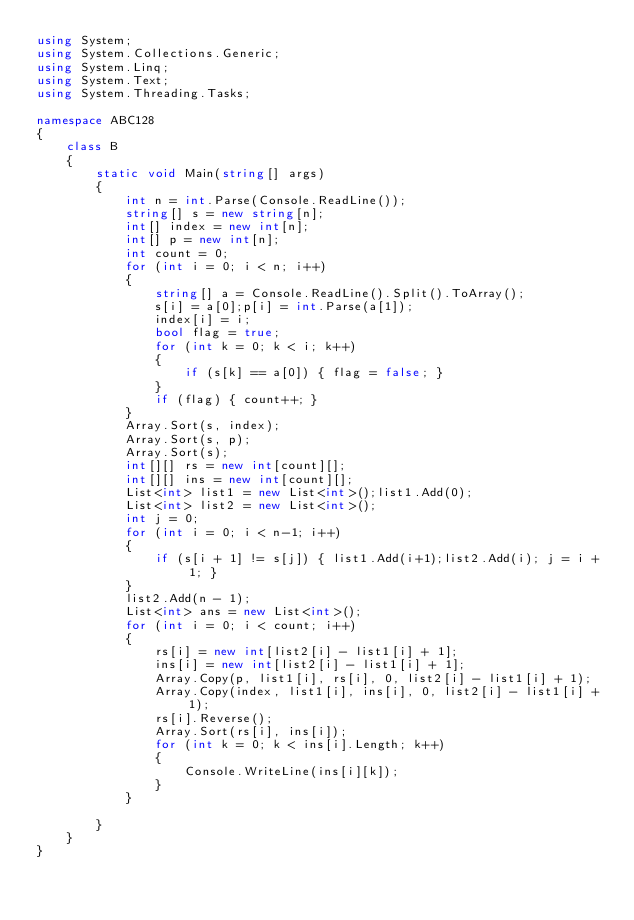Convert code to text. <code><loc_0><loc_0><loc_500><loc_500><_C#_>using System;
using System.Collections.Generic;
using System.Linq;
using System.Text;
using System.Threading.Tasks;

namespace ABC128
{
    class B
    {
        static void Main(string[] args)
        {
            int n = int.Parse(Console.ReadLine());
            string[] s = new string[n];
            int[] index = new int[n];
            int[] p = new int[n];
            int count = 0;
            for (int i = 0; i < n; i++)
            {
                string[] a = Console.ReadLine().Split().ToArray();
                s[i] = a[0];p[i] = int.Parse(a[1]);
                index[i] = i;
                bool flag = true;
                for (int k = 0; k < i; k++)
                {
                    if (s[k] == a[0]) { flag = false; }
                }
                if (flag) { count++; }
            }
            Array.Sort(s, index);
            Array.Sort(s, p);
            Array.Sort(s);
            int[][] rs = new int[count][];
            int[][] ins = new int[count][];
            List<int> list1 = new List<int>();list1.Add(0);
            List<int> list2 = new List<int>();
            int j = 0;
            for (int i = 0; i < n-1; i++)
            {
                if (s[i + 1] != s[j]) { list1.Add(i+1);list2.Add(i); j = i + 1; }
            }
            list2.Add(n - 1);
            List<int> ans = new List<int>();
            for (int i = 0; i < count; i++)
            {
                rs[i] = new int[list2[i] - list1[i] + 1];
                ins[i] = new int[list2[i] - list1[i] + 1];
                Array.Copy(p, list1[i], rs[i], 0, list2[i] - list1[i] + 1);
                Array.Copy(index, list1[i], ins[i], 0, list2[i] - list1[i] + 1);
                rs[i].Reverse();
                Array.Sort(rs[i], ins[i]);
                for (int k = 0; k < ins[i].Length; k++)
                {
                    Console.WriteLine(ins[i][k]);
                }
            }

        }
    }
}
</code> 